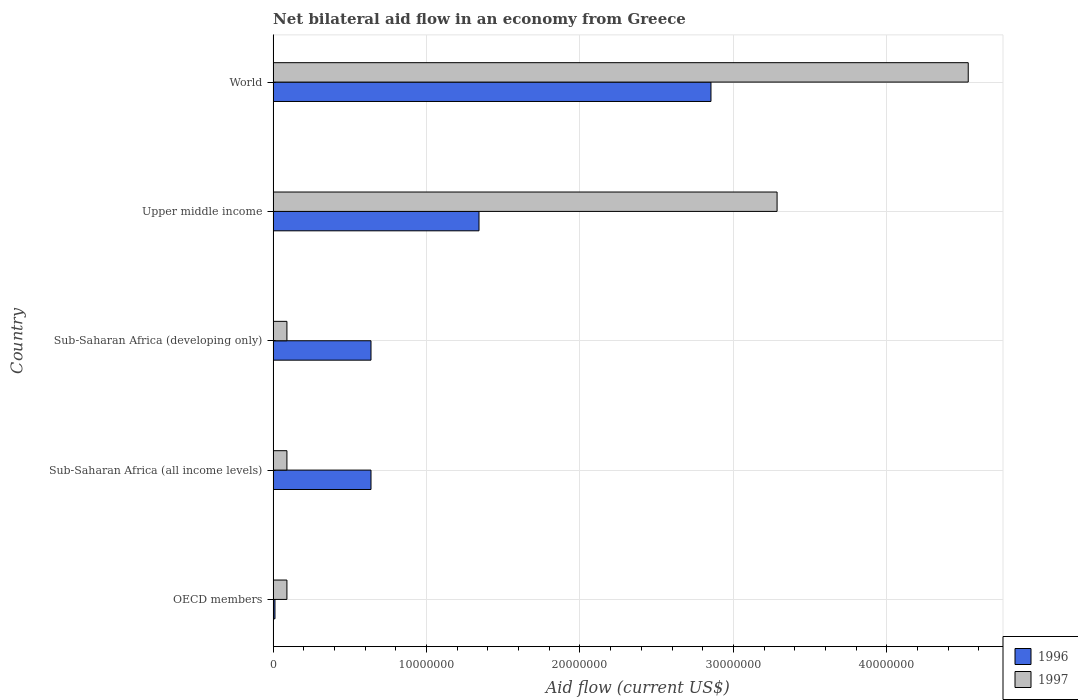How many different coloured bars are there?
Offer a terse response. 2. How many groups of bars are there?
Make the answer very short. 5. Are the number of bars per tick equal to the number of legend labels?
Offer a very short reply. Yes. How many bars are there on the 5th tick from the top?
Your answer should be compact. 2. What is the label of the 1st group of bars from the top?
Provide a short and direct response. World. Across all countries, what is the maximum net bilateral aid flow in 1996?
Your answer should be compact. 2.85e+07. What is the total net bilateral aid flow in 1996 in the graph?
Your answer should be compact. 5.48e+07. What is the difference between the net bilateral aid flow in 1997 in Sub-Saharan Africa (developing only) and that in Upper middle income?
Your answer should be compact. -3.20e+07. What is the difference between the net bilateral aid flow in 1997 in World and the net bilateral aid flow in 1996 in Sub-Saharan Africa (developing only)?
Provide a succinct answer. 3.89e+07. What is the average net bilateral aid flow in 1997 per country?
Provide a succinct answer. 1.62e+07. What is the difference between the net bilateral aid flow in 1997 and net bilateral aid flow in 1996 in Sub-Saharan Africa (developing only)?
Your response must be concise. -5.48e+06. In how many countries, is the net bilateral aid flow in 1997 greater than 42000000 US$?
Your answer should be compact. 1. What is the ratio of the net bilateral aid flow in 1996 in OECD members to that in Sub-Saharan Africa (all income levels)?
Provide a succinct answer. 0.02. Is the net bilateral aid flow in 1997 in Sub-Saharan Africa (developing only) less than that in World?
Make the answer very short. Yes. What is the difference between the highest and the second highest net bilateral aid flow in 1996?
Provide a succinct answer. 1.51e+07. What is the difference between the highest and the lowest net bilateral aid flow in 1997?
Ensure brevity in your answer.  4.44e+07. Are all the bars in the graph horizontal?
Offer a very short reply. Yes. How many countries are there in the graph?
Your response must be concise. 5. Does the graph contain any zero values?
Make the answer very short. No. Where does the legend appear in the graph?
Make the answer very short. Bottom right. How are the legend labels stacked?
Provide a succinct answer. Vertical. What is the title of the graph?
Your response must be concise. Net bilateral aid flow in an economy from Greece. Does "2011" appear as one of the legend labels in the graph?
Make the answer very short. No. What is the Aid flow (current US$) in 1997 in OECD members?
Offer a very short reply. 9.00e+05. What is the Aid flow (current US$) of 1996 in Sub-Saharan Africa (all income levels)?
Provide a succinct answer. 6.38e+06. What is the Aid flow (current US$) in 1997 in Sub-Saharan Africa (all income levels)?
Ensure brevity in your answer.  9.00e+05. What is the Aid flow (current US$) in 1996 in Sub-Saharan Africa (developing only)?
Keep it short and to the point. 6.38e+06. What is the Aid flow (current US$) in 1997 in Sub-Saharan Africa (developing only)?
Offer a terse response. 9.00e+05. What is the Aid flow (current US$) in 1996 in Upper middle income?
Keep it short and to the point. 1.34e+07. What is the Aid flow (current US$) of 1997 in Upper middle income?
Your answer should be very brief. 3.28e+07. What is the Aid flow (current US$) of 1996 in World?
Your answer should be compact. 2.85e+07. What is the Aid flow (current US$) of 1997 in World?
Offer a terse response. 4.53e+07. Across all countries, what is the maximum Aid flow (current US$) in 1996?
Your answer should be very brief. 2.85e+07. Across all countries, what is the maximum Aid flow (current US$) of 1997?
Keep it short and to the point. 4.53e+07. Across all countries, what is the minimum Aid flow (current US$) in 1996?
Offer a very short reply. 1.20e+05. Across all countries, what is the minimum Aid flow (current US$) in 1997?
Your answer should be compact. 9.00e+05. What is the total Aid flow (current US$) of 1996 in the graph?
Give a very brief answer. 5.48e+07. What is the total Aid flow (current US$) of 1997 in the graph?
Give a very brief answer. 8.09e+07. What is the difference between the Aid flow (current US$) in 1996 in OECD members and that in Sub-Saharan Africa (all income levels)?
Ensure brevity in your answer.  -6.26e+06. What is the difference between the Aid flow (current US$) of 1996 in OECD members and that in Sub-Saharan Africa (developing only)?
Ensure brevity in your answer.  -6.26e+06. What is the difference between the Aid flow (current US$) in 1996 in OECD members and that in Upper middle income?
Keep it short and to the point. -1.33e+07. What is the difference between the Aid flow (current US$) in 1997 in OECD members and that in Upper middle income?
Provide a short and direct response. -3.20e+07. What is the difference between the Aid flow (current US$) of 1996 in OECD members and that in World?
Offer a terse response. -2.84e+07. What is the difference between the Aid flow (current US$) of 1997 in OECD members and that in World?
Provide a succinct answer. -4.44e+07. What is the difference between the Aid flow (current US$) in 1996 in Sub-Saharan Africa (all income levels) and that in Sub-Saharan Africa (developing only)?
Offer a terse response. 0. What is the difference between the Aid flow (current US$) of 1996 in Sub-Saharan Africa (all income levels) and that in Upper middle income?
Give a very brief answer. -7.04e+06. What is the difference between the Aid flow (current US$) of 1997 in Sub-Saharan Africa (all income levels) and that in Upper middle income?
Ensure brevity in your answer.  -3.20e+07. What is the difference between the Aid flow (current US$) in 1996 in Sub-Saharan Africa (all income levels) and that in World?
Provide a succinct answer. -2.22e+07. What is the difference between the Aid flow (current US$) of 1997 in Sub-Saharan Africa (all income levels) and that in World?
Make the answer very short. -4.44e+07. What is the difference between the Aid flow (current US$) in 1996 in Sub-Saharan Africa (developing only) and that in Upper middle income?
Make the answer very short. -7.04e+06. What is the difference between the Aid flow (current US$) of 1997 in Sub-Saharan Africa (developing only) and that in Upper middle income?
Make the answer very short. -3.20e+07. What is the difference between the Aid flow (current US$) of 1996 in Sub-Saharan Africa (developing only) and that in World?
Make the answer very short. -2.22e+07. What is the difference between the Aid flow (current US$) of 1997 in Sub-Saharan Africa (developing only) and that in World?
Provide a short and direct response. -4.44e+07. What is the difference between the Aid flow (current US$) of 1996 in Upper middle income and that in World?
Your answer should be very brief. -1.51e+07. What is the difference between the Aid flow (current US$) in 1997 in Upper middle income and that in World?
Ensure brevity in your answer.  -1.25e+07. What is the difference between the Aid flow (current US$) of 1996 in OECD members and the Aid flow (current US$) of 1997 in Sub-Saharan Africa (all income levels)?
Make the answer very short. -7.80e+05. What is the difference between the Aid flow (current US$) in 1996 in OECD members and the Aid flow (current US$) in 1997 in Sub-Saharan Africa (developing only)?
Provide a succinct answer. -7.80e+05. What is the difference between the Aid flow (current US$) of 1996 in OECD members and the Aid flow (current US$) of 1997 in Upper middle income?
Give a very brief answer. -3.27e+07. What is the difference between the Aid flow (current US$) of 1996 in OECD members and the Aid flow (current US$) of 1997 in World?
Provide a short and direct response. -4.52e+07. What is the difference between the Aid flow (current US$) of 1996 in Sub-Saharan Africa (all income levels) and the Aid flow (current US$) of 1997 in Sub-Saharan Africa (developing only)?
Give a very brief answer. 5.48e+06. What is the difference between the Aid flow (current US$) of 1996 in Sub-Saharan Africa (all income levels) and the Aid flow (current US$) of 1997 in Upper middle income?
Keep it short and to the point. -2.65e+07. What is the difference between the Aid flow (current US$) in 1996 in Sub-Saharan Africa (all income levels) and the Aid flow (current US$) in 1997 in World?
Make the answer very short. -3.89e+07. What is the difference between the Aid flow (current US$) of 1996 in Sub-Saharan Africa (developing only) and the Aid flow (current US$) of 1997 in Upper middle income?
Your answer should be very brief. -2.65e+07. What is the difference between the Aid flow (current US$) of 1996 in Sub-Saharan Africa (developing only) and the Aid flow (current US$) of 1997 in World?
Keep it short and to the point. -3.89e+07. What is the difference between the Aid flow (current US$) of 1996 in Upper middle income and the Aid flow (current US$) of 1997 in World?
Ensure brevity in your answer.  -3.19e+07. What is the average Aid flow (current US$) in 1996 per country?
Your answer should be compact. 1.10e+07. What is the average Aid flow (current US$) of 1997 per country?
Give a very brief answer. 1.62e+07. What is the difference between the Aid flow (current US$) of 1996 and Aid flow (current US$) of 1997 in OECD members?
Offer a very short reply. -7.80e+05. What is the difference between the Aid flow (current US$) of 1996 and Aid flow (current US$) of 1997 in Sub-Saharan Africa (all income levels)?
Keep it short and to the point. 5.48e+06. What is the difference between the Aid flow (current US$) of 1996 and Aid flow (current US$) of 1997 in Sub-Saharan Africa (developing only)?
Offer a terse response. 5.48e+06. What is the difference between the Aid flow (current US$) of 1996 and Aid flow (current US$) of 1997 in Upper middle income?
Offer a terse response. -1.94e+07. What is the difference between the Aid flow (current US$) in 1996 and Aid flow (current US$) in 1997 in World?
Offer a very short reply. -1.68e+07. What is the ratio of the Aid flow (current US$) in 1996 in OECD members to that in Sub-Saharan Africa (all income levels)?
Offer a very short reply. 0.02. What is the ratio of the Aid flow (current US$) in 1996 in OECD members to that in Sub-Saharan Africa (developing only)?
Give a very brief answer. 0.02. What is the ratio of the Aid flow (current US$) in 1996 in OECD members to that in Upper middle income?
Offer a very short reply. 0.01. What is the ratio of the Aid flow (current US$) of 1997 in OECD members to that in Upper middle income?
Provide a short and direct response. 0.03. What is the ratio of the Aid flow (current US$) in 1996 in OECD members to that in World?
Make the answer very short. 0. What is the ratio of the Aid flow (current US$) of 1997 in OECD members to that in World?
Make the answer very short. 0.02. What is the ratio of the Aid flow (current US$) of 1996 in Sub-Saharan Africa (all income levels) to that in Upper middle income?
Your answer should be very brief. 0.48. What is the ratio of the Aid flow (current US$) of 1997 in Sub-Saharan Africa (all income levels) to that in Upper middle income?
Your answer should be compact. 0.03. What is the ratio of the Aid flow (current US$) of 1996 in Sub-Saharan Africa (all income levels) to that in World?
Ensure brevity in your answer.  0.22. What is the ratio of the Aid flow (current US$) in 1997 in Sub-Saharan Africa (all income levels) to that in World?
Give a very brief answer. 0.02. What is the ratio of the Aid flow (current US$) of 1996 in Sub-Saharan Africa (developing only) to that in Upper middle income?
Offer a terse response. 0.48. What is the ratio of the Aid flow (current US$) in 1997 in Sub-Saharan Africa (developing only) to that in Upper middle income?
Offer a very short reply. 0.03. What is the ratio of the Aid flow (current US$) of 1996 in Sub-Saharan Africa (developing only) to that in World?
Keep it short and to the point. 0.22. What is the ratio of the Aid flow (current US$) in 1997 in Sub-Saharan Africa (developing only) to that in World?
Offer a very short reply. 0.02. What is the ratio of the Aid flow (current US$) of 1996 in Upper middle income to that in World?
Give a very brief answer. 0.47. What is the ratio of the Aid flow (current US$) in 1997 in Upper middle income to that in World?
Keep it short and to the point. 0.72. What is the difference between the highest and the second highest Aid flow (current US$) of 1996?
Provide a short and direct response. 1.51e+07. What is the difference between the highest and the second highest Aid flow (current US$) of 1997?
Your answer should be very brief. 1.25e+07. What is the difference between the highest and the lowest Aid flow (current US$) in 1996?
Give a very brief answer. 2.84e+07. What is the difference between the highest and the lowest Aid flow (current US$) of 1997?
Your answer should be compact. 4.44e+07. 